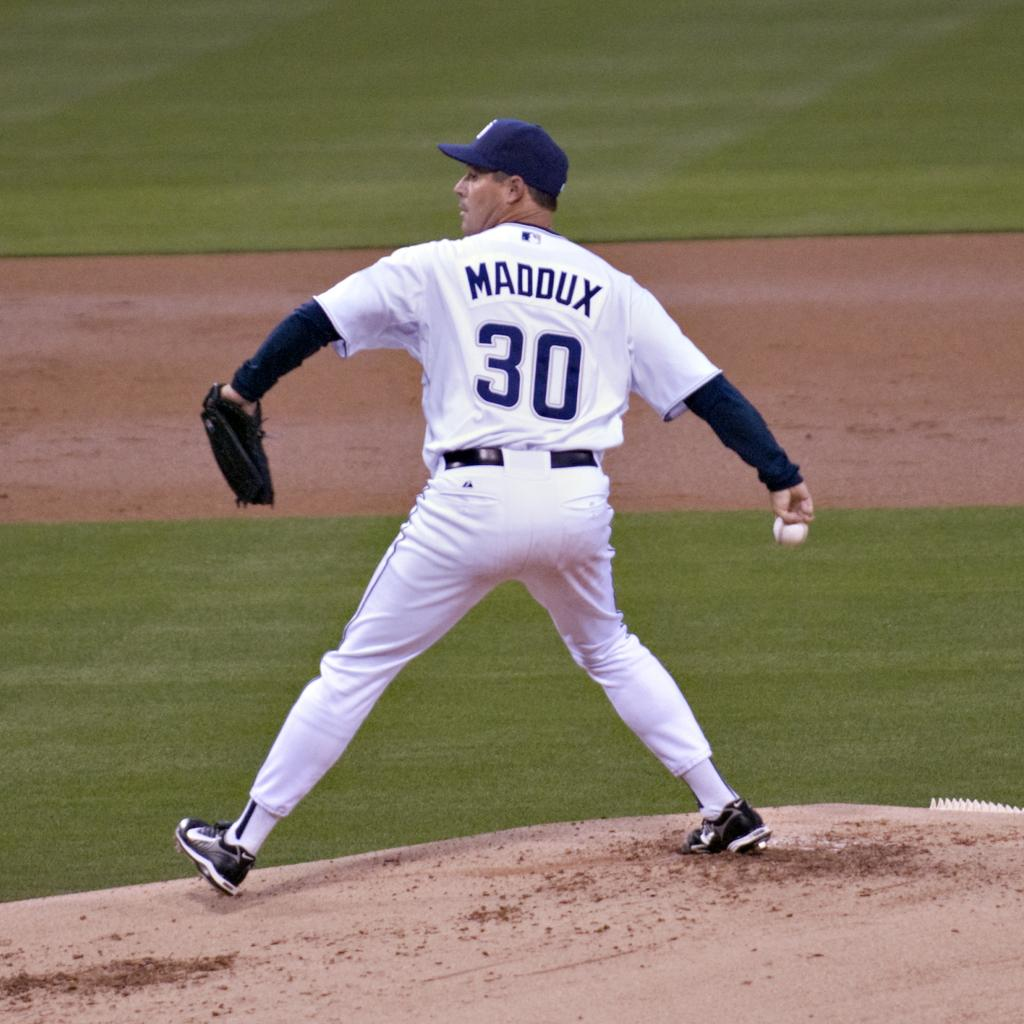<image>
Write a terse but informative summary of the picture. Number 30 Maddux winds up to throw a baseball. 